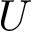Convert formula to latex. <formula><loc_0><loc_0><loc_500><loc_500>U</formula> 